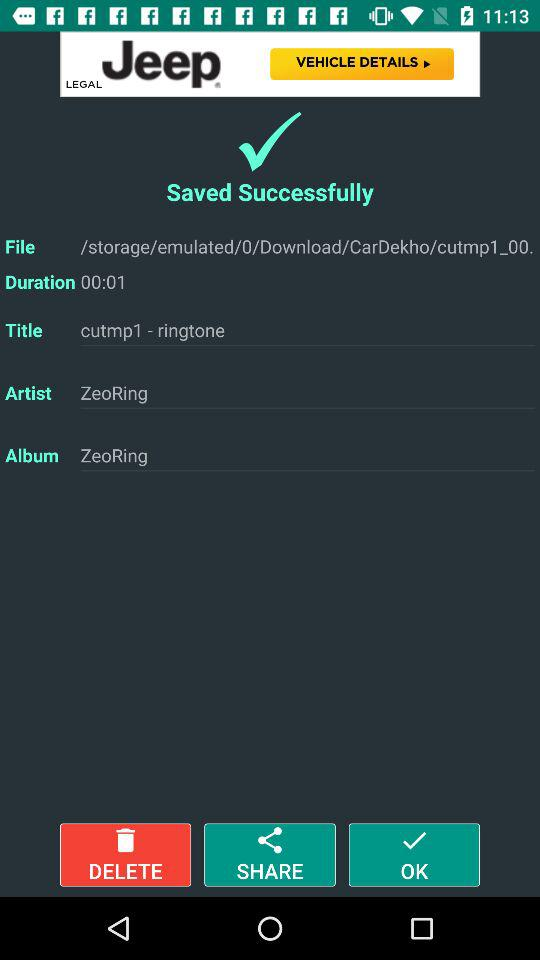What is the album name? The album name is "ZeoRing". 